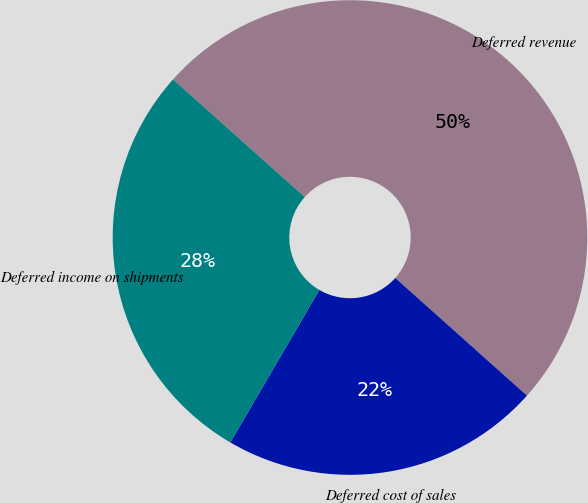Convert chart to OTSL. <chart><loc_0><loc_0><loc_500><loc_500><pie_chart><fcel>Deferred revenue<fcel>Deferred cost of sales<fcel>Deferred income on shipments<nl><fcel>50.0%<fcel>21.81%<fcel>28.19%<nl></chart> 